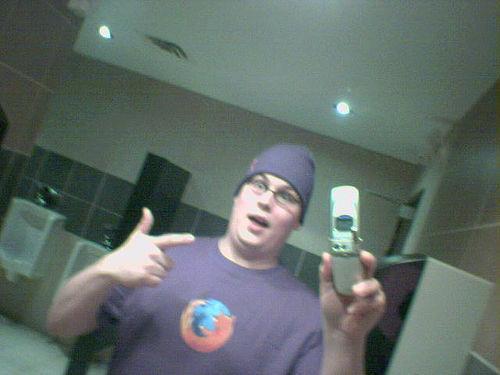How many skateboards are pictured off the ground?
Give a very brief answer. 0. 